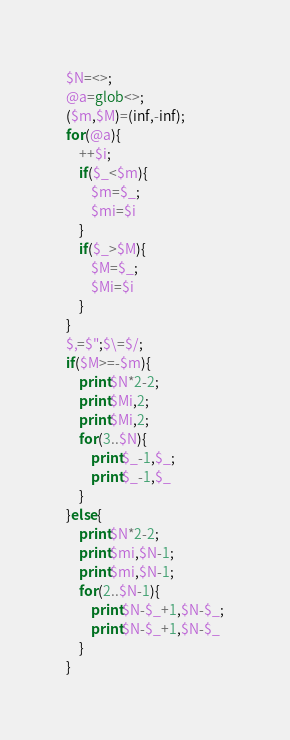Convert code to text. <code><loc_0><loc_0><loc_500><loc_500><_Perl_>$N=<>;
@a=glob<>;
($m,$M)=(inf,-inf);
for(@a){
	++$i;
	if($_<$m){
		$m=$_;
		$mi=$i
	}
	if($_>$M){
		$M=$_;
		$Mi=$i
	}
}
$,=$";$\=$/;
if($M>=-$m){
	print$N*2-2;
	print$Mi,2;
	print$Mi,2;
	for(3..$N){
		print$_-1,$_;
		print$_-1,$_
	}
}else{
	print$N*2-2;
	print$mi,$N-1;
	print$mi,$N-1;
	for(2..$N-1){
		print$N-$_+1,$N-$_;
		print$N-$_+1,$N-$_
	}
}
</code> 